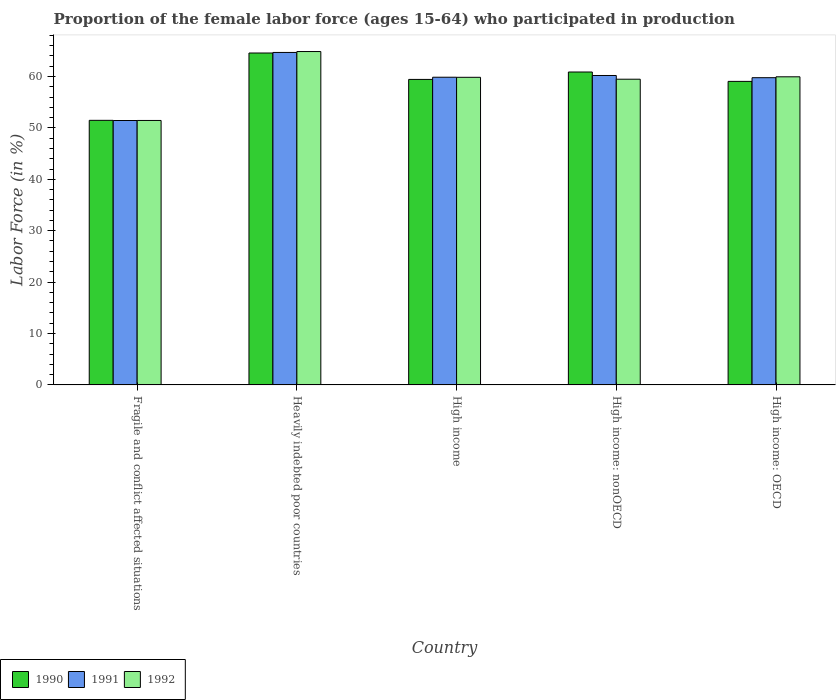How many groups of bars are there?
Keep it short and to the point. 5. Are the number of bars per tick equal to the number of legend labels?
Your answer should be compact. Yes. Are the number of bars on each tick of the X-axis equal?
Make the answer very short. Yes. How many bars are there on the 3rd tick from the left?
Provide a succinct answer. 3. How many bars are there on the 5th tick from the right?
Give a very brief answer. 3. What is the label of the 5th group of bars from the left?
Your response must be concise. High income: OECD. What is the proportion of the female labor force who participated in production in 1992 in Heavily indebted poor countries?
Keep it short and to the point. 64.85. Across all countries, what is the maximum proportion of the female labor force who participated in production in 1990?
Provide a short and direct response. 64.57. Across all countries, what is the minimum proportion of the female labor force who participated in production in 1992?
Your answer should be very brief. 51.44. In which country was the proportion of the female labor force who participated in production in 1992 maximum?
Your answer should be compact. Heavily indebted poor countries. In which country was the proportion of the female labor force who participated in production in 1990 minimum?
Keep it short and to the point. Fragile and conflict affected situations. What is the total proportion of the female labor force who participated in production in 1991 in the graph?
Make the answer very short. 295.93. What is the difference between the proportion of the female labor force who participated in production in 1991 in Fragile and conflict affected situations and that in Heavily indebted poor countries?
Your answer should be compact. -13.24. What is the difference between the proportion of the female labor force who participated in production in 1992 in High income: nonOECD and the proportion of the female labor force who participated in production in 1991 in High income?
Your answer should be compact. -0.38. What is the average proportion of the female labor force who participated in production in 1992 per country?
Your answer should be compact. 59.11. What is the difference between the proportion of the female labor force who participated in production of/in 1992 and proportion of the female labor force who participated in production of/in 1990 in Fragile and conflict affected situations?
Keep it short and to the point. -0.03. What is the ratio of the proportion of the female labor force who participated in production in 1990 in Fragile and conflict affected situations to that in High income: nonOECD?
Keep it short and to the point. 0.85. Is the proportion of the female labor force who participated in production in 1991 in Fragile and conflict affected situations less than that in High income: nonOECD?
Give a very brief answer. Yes. What is the difference between the highest and the second highest proportion of the female labor force who participated in production in 1992?
Provide a succinct answer. 5.01. What is the difference between the highest and the lowest proportion of the female labor force who participated in production in 1992?
Your answer should be very brief. 13.41. Is the sum of the proportion of the female labor force who participated in production in 1991 in Heavily indebted poor countries and High income: nonOECD greater than the maximum proportion of the female labor force who participated in production in 1992 across all countries?
Make the answer very short. Yes. Is it the case that in every country, the sum of the proportion of the female labor force who participated in production in 1991 and proportion of the female labor force who participated in production in 1992 is greater than the proportion of the female labor force who participated in production in 1990?
Provide a short and direct response. Yes. Are all the bars in the graph horizontal?
Offer a very short reply. No. How many countries are there in the graph?
Give a very brief answer. 5. Are the values on the major ticks of Y-axis written in scientific E-notation?
Offer a terse response. No. Does the graph contain grids?
Offer a terse response. No. Where does the legend appear in the graph?
Give a very brief answer. Bottom left. How are the legend labels stacked?
Provide a succinct answer. Horizontal. What is the title of the graph?
Your response must be concise. Proportion of the female labor force (ages 15-64) who participated in production. Does "1973" appear as one of the legend labels in the graph?
Give a very brief answer. No. What is the Labor Force (in %) of 1990 in Fragile and conflict affected situations?
Give a very brief answer. 51.47. What is the Labor Force (in %) in 1991 in Fragile and conflict affected situations?
Provide a succinct answer. 51.44. What is the Labor Force (in %) of 1992 in Fragile and conflict affected situations?
Keep it short and to the point. 51.44. What is the Labor Force (in %) of 1990 in Heavily indebted poor countries?
Your answer should be very brief. 64.57. What is the Labor Force (in %) in 1991 in Heavily indebted poor countries?
Provide a short and direct response. 64.68. What is the Labor Force (in %) of 1992 in Heavily indebted poor countries?
Provide a short and direct response. 64.85. What is the Labor Force (in %) of 1990 in High income?
Offer a very short reply. 59.43. What is the Labor Force (in %) in 1991 in High income?
Keep it short and to the point. 59.86. What is the Labor Force (in %) of 1992 in High income?
Provide a succinct answer. 59.84. What is the Labor Force (in %) in 1990 in High income: nonOECD?
Provide a short and direct response. 60.87. What is the Labor Force (in %) of 1991 in High income: nonOECD?
Your response must be concise. 60.19. What is the Labor Force (in %) in 1992 in High income: nonOECD?
Provide a short and direct response. 59.47. What is the Labor Force (in %) in 1990 in High income: OECD?
Your answer should be very brief. 59.05. What is the Labor Force (in %) of 1991 in High income: OECD?
Your answer should be compact. 59.77. What is the Labor Force (in %) in 1992 in High income: OECD?
Provide a succinct answer. 59.94. Across all countries, what is the maximum Labor Force (in %) of 1990?
Provide a short and direct response. 64.57. Across all countries, what is the maximum Labor Force (in %) in 1991?
Provide a short and direct response. 64.68. Across all countries, what is the maximum Labor Force (in %) in 1992?
Ensure brevity in your answer.  64.85. Across all countries, what is the minimum Labor Force (in %) in 1990?
Your response must be concise. 51.47. Across all countries, what is the minimum Labor Force (in %) in 1991?
Your answer should be very brief. 51.44. Across all countries, what is the minimum Labor Force (in %) in 1992?
Your response must be concise. 51.44. What is the total Labor Force (in %) of 1990 in the graph?
Provide a succinct answer. 295.39. What is the total Labor Force (in %) of 1991 in the graph?
Offer a terse response. 295.93. What is the total Labor Force (in %) in 1992 in the graph?
Make the answer very short. 295.55. What is the difference between the Labor Force (in %) in 1990 in Fragile and conflict affected situations and that in Heavily indebted poor countries?
Keep it short and to the point. -13.1. What is the difference between the Labor Force (in %) of 1991 in Fragile and conflict affected situations and that in Heavily indebted poor countries?
Provide a short and direct response. -13.24. What is the difference between the Labor Force (in %) in 1992 in Fragile and conflict affected situations and that in Heavily indebted poor countries?
Make the answer very short. -13.41. What is the difference between the Labor Force (in %) in 1990 in Fragile and conflict affected situations and that in High income?
Give a very brief answer. -7.96. What is the difference between the Labor Force (in %) in 1991 in Fragile and conflict affected situations and that in High income?
Give a very brief answer. -8.42. What is the difference between the Labor Force (in %) in 1992 in Fragile and conflict affected situations and that in High income?
Your response must be concise. -8.4. What is the difference between the Labor Force (in %) in 1990 in Fragile and conflict affected situations and that in High income: nonOECD?
Make the answer very short. -9.4. What is the difference between the Labor Force (in %) of 1991 in Fragile and conflict affected situations and that in High income: nonOECD?
Your answer should be very brief. -8.76. What is the difference between the Labor Force (in %) in 1992 in Fragile and conflict affected situations and that in High income: nonOECD?
Ensure brevity in your answer.  -8.03. What is the difference between the Labor Force (in %) of 1990 in Fragile and conflict affected situations and that in High income: OECD?
Provide a short and direct response. -7.58. What is the difference between the Labor Force (in %) in 1991 in Fragile and conflict affected situations and that in High income: OECD?
Your answer should be very brief. -8.33. What is the difference between the Labor Force (in %) of 1992 in Fragile and conflict affected situations and that in High income: OECD?
Give a very brief answer. -8.49. What is the difference between the Labor Force (in %) in 1990 in Heavily indebted poor countries and that in High income?
Provide a succinct answer. 5.14. What is the difference between the Labor Force (in %) of 1991 in Heavily indebted poor countries and that in High income?
Offer a very short reply. 4.82. What is the difference between the Labor Force (in %) of 1992 in Heavily indebted poor countries and that in High income?
Your answer should be compact. 5.01. What is the difference between the Labor Force (in %) in 1990 in Heavily indebted poor countries and that in High income: nonOECD?
Make the answer very short. 3.7. What is the difference between the Labor Force (in %) of 1991 in Heavily indebted poor countries and that in High income: nonOECD?
Keep it short and to the point. 4.48. What is the difference between the Labor Force (in %) in 1992 in Heavily indebted poor countries and that in High income: nonOECD?
Offer a terse response. 5.38. What is the difference between the Labor Force (in %) of 1990 in Heavily indebted poor countries and that in High income: OECD?
Give a very brief answer. 5.52. What is the difference between the Labor Force (in %) in 1991 in Heavily indebted poor countries and that in High income: OECD?
Make the answer very short. 4.91. What is the difference between the Labor Force (in %) in 1992 in Heavily indebted poor countries and that in High income: OECD?
Your response must be concise. 4.91. What is the difference between the Labor Force (in %) in 1990 in High income and that in High income: nonOECD?
Provide a short and direct response. -1.44. What is the difference between the Labor Force (in %) in 1991 in High income and that in High income: nonOECD?
Ensure brevity in your answer.  -0.34. What is the difference between the Labor Force (in %) of 1992 in High income and that in High income: nonOECD?
Provide a short and direct response. 0.37. What is the difference between the Labor Force (in %) of 1990 in High income and that in High income: OECD?
Provide a short and direct response. 0.38. What is the difference between the Labor Force (in %) of 1991 in High income and that in High income: OECD?
Your answer should be compact. 0.09. What is the difference between the Labor Force (in %) of 1992 in High income and that in High income: OECD?
Give a very brief answer. -0.1. What is the difference between the Labor Force (in %) in 1990 in High income: nonOECD and that in High income: OECD?
Keep it short and to the point. 1.82. What is the difference between the Labor Force (in %) in 1991 in High income: nonOECD and that in High income: OECD?
Provide a short and direct response. 0.43. What is the difference between the Labor Force (in %) of 1992 in High income: nonOECD and that in High income: OECD?
Offer a terse response. -0.47. What is the difference between the Labor Force (in %) of 1990 in Fragile and conflict affected situations and the Labor Force (in %) of 1991 in Heavily indebted poor countries?
Keep it short and to the point. -13.21. What is the difference between the Labor Force (in %) of 1990 in Fragile and conflict affected situations and the Labor Force (in %) of 1992 in Heavily indebted poor countries?
Your answer should be compact. -13.38. What is the difference between the Labor Force (in %) of 1991 in Fragile and conflict affected situations and the Labor Force (in %) of 1992 in Heavily indebted poor countries?
Keep it short and to the point. -13.42. What is the difference between the Labor Force (in %) of 1990 in Fragile and conflict affected situations and the Labor Force (in %) of 1991 in High income?
Make the answer very short. -8.38. What is the difference between the Labor Force (in %) of 1990 in Fragile and conflict affected situations and the Labor Force (in %) of 1992 in High income?
Your response must be concise. -8.37. What is the difference between the Labor Force (in %) of 1991 in Fragile and conflict affected situations and the Labor Force (in %) of 1992 in High income?
Your answer should be compact. -8.4. What is the difference between the Labor Force (in %) in 1990 in Fragile and conflict affected situations and the Labor Force (in %) in 1991 in High income: nonOECD?
Offer a terse response. -8.72. What is the difference between the Labor Force (in %) in 1990 in Fragile and conflict affected situations and the Labor Force (in %) in 1992 in High income: nonOECD?
Provide a short and direct response. -8. What is the difference between the Labor Force (in %) of 1991 in Fragile and conflict affected situations and the Labor Force (in %) of 1992 in High income: nonOECD?
Your response must be concise. -8.03. What is the difference between the Labor Force (in %) of 1990 in Fragile and conflict affected situations and the Labor Force (in %) of 1991 in High income: OECD?
Offer a terse response. -8.3. What is the difference between the Labor Force (in %) in 1990 in Fragile and conflict affected situations and the Labor Force (in %) in 1992 in High income: OECD?
Your answer should be compact. -8.47. What is the difference between the Labor Force (in %) of 1991 in Fragile and conflict affected situations and the Labor Force (in %) of 1992 in High income: OECD?
Offer a very short reply. -8.5. What is the difference between the Labor Force (in %) in 1990 in Heavily indebted poor countries and the Labor Force (in %) in 1991 in High income?
Make the answer very short. 4.71. What is the difference between the Labor Force (in %) of 1990 in Heavily indebted poor countries and the Labor Force (in %) of 1992 in High income?
Provide a succinct answer. 4.73. What is the difference between the Labor Force (in %) of 1991 in Heavily indebted poor countries and the Labor Force (in %) of 1992 in High income?
Ensure brevity in your answer.  4.84. What is the difference between the Labor Force (in %) in 1990 in Heavily indebted poor countries and the Labor Force (in %) in 1991 in High income: nonOECD?
Your answer should be compact. 4.37. What is the difference between the Labor Force (in %) in 1990 in Heavily indebted poor countries and the Labor Force (in %) in 1992 in High income: nonOECD?
Offer a very short reply. 5.1. What is the difference between the Labor Force (in %) of 1991 in Heavily indebted poor countries and the Labor Force (in %) of 1992 in High income: nonOECD?
Your answer should be very brief. 5.21. What is the difference between the Labor Force (in %) in 1990 in Heavily indebted poor countries and the Labor Force (in %) in 1991 in High income: OECD?
Provide a short and direct response. 4.8. What is the difference between the Labor Force (in %) of 1990 in Heavily indebted poor countries and the Labor Force (in %) of 1992 in High income: OECD?
Make the answer very short. 4.63. What is the difference between the Labor Force (in %) in 1991 in Heavily indebted poor countries and the Labor Force (in %) in 1992 in High income: OECD?
Your response must be concise. 4.74. What is the difference between the Labor Force (in %) in 1990 in High income and the Labor Force (in %) in 1991 in High income: nonOECD?
Provide a short and direct response. -0.76. What is the difference between the Labor Force (in %) of 1990 in High income and the Labor Force (in %) of 1992 in High income: nonOECD?
Offer a very short reply. -0.04. What is the difference between the Labor Force (in %) of 1991 in High income and the Labor Force (in %) of 1992 in High income: nonOECD?
Ensure brevity in your answer.  0.38. What is the difference between the Labor Force (in %) in 1990 in High income and the Labor Force (in %) in 1991 in High income: OECD?
Offer a very short reply. -0.34. What is the difference between the Labor Force (in %) in 1990 in High income and the Labor Force (in %) in 1992 in High income: OECD?
Provide a short and direct response. -0.51. What is the difference between the Labor Force (in %) in 1991 in High income and the Labor Force (in %) in 1992 in High income: OECD?
Offer a terse response. -0.08. What is the difference between the Labor Force (in %) in 1990 in High income: nonOECD and the Labor Force (in %) in 1991 in High income: OECD?
Make the answer very short. 1.11. What is the difference between the Labor Force (in %) of 1990 in High income: nonOECD and the Labor Force (in %) of 1992 in High income: OECD?
Your response must be concise. 0.93. What is the difference between the Labor Force (in %) in 1991 in High income: nonOECD and the Labor Force (in %) in 1992 in High income: OECD?
Keep it short and to the point. 0.25. What is the average Labor Force (in %) in 1990 per country?
Your answer should be compact. 59.08. What is the average Labor Force (in %) in 1991 per country?
Your response must be concise. 59.19. What is the average Labor Force (in %) of 1992 per country?
Provide a short and direct response. 59.11. What is the difference between the Labor Force (in %) in 1990 and Labor Force (in %) in 1991 in Fragile and conflict affected situations?
Keep it short and to the point. 0.03. What is the difference between the Labor Force (in %) in 1990 and Labor Force (in %) in 1992 in Fragile and conflict affected situations?
Make the answer very short. 0.03. What is the difference between the Labor Force (in %) in 1991 and Labor Force (in %) in 1992 in Fragile and conflict affected situations?
Offer a terse response. -0.01. What is the difference between the Labor Force (in %) in 1990 and Labor Force (in %) in 1991 in Heavily indebted poor countries?
Keep it short and to the point. -0.11. What is the difference between the Labor Force (in %) in 1990 and Labor Force (in %) in 1992 in Heavily indebted poor countries?
Provide a succinct answer. -0.28. What is the difference between the Labor Force (in %) in 1991 and Labor Force (in %) in 1992 in Heavily indebted poor countries?
Offer a very short reply. -0.18. What is the difference between the Labor Force (in %) of 1990 and Labor Force (in %) of 1991 in High income?
Offer a terse response. -0.43. What is the difference between the Labor Force (in %) of 1990 and Labor Force (in %) of 1992 in High income?
Provide a short and direct response. -0.41. What is the difference between the Labor Force (in %) of 1991 and Labor Force (in %) of 1992 in High income?
Offer a very short reply. 0.01. What is the difference between the Labor Force (in %) of 1990 and Labor Force (in %) of 1991 in High income: nonOECD?
Make the answer very short. 0.68. What is the difference between the Labor Force (in %) of 1990 and Labor Force (in %) of 1992 in High income: nonOECD?
Your answer should be compact. 1.4. What is the difference between the Labor Force (in %) of 1991 and Labor Force (in %) of 1992 in High income: nonOECD?
Offer a terse response. 0.72. What is the difference between the Labor Force (in %) of 1990 and Labor Force (in %) of 1991 in High income: OECD?
Your answer should be compact. -0.72. What is the difference between the Labor Force (in %) in 1990 and Labor Force (in %) in 1992 in High income: OECD?
Your answer should be very brief. -0.89. What is the difference between the Labor Force (in %) in 1991 and Labor Force (in %) in 1992 in High income: OECD?
Make the answer very short. -0.17. What is the ratio of the Labor Force (in %) of 1990 in Fragile and conflict affected situations to that in Heavily indebted poor countries?
Offer a terse response. 0.8. What is the ratio of the Labor Force (in %) of 1991 in Fragile and conflict affected situations to that in Heavily indebted poor countries?
Your response must be concise. 0.8. What is the ratio of the Labor Force (in %) in 1992 in Fragile and conflict affected situations to that in Heavily indebted poor countries?
Give a very brief answer. 0.79. What is the ratio of the Labor Force (in %) in 1990 in Fragile and conflict affected situations to that in High income?
Keep it short and to the point. 0.87. What is the ratio of the Labor Force (in %) in 1991 in Fragile and conflict affected situations to that in High income?
Make the answer very short. 0.86. What is the ratio of the Labor Force (in %) in 1992 in Fragile and conflict affected situations to that in High income?
Offer a terse response. 0.86. What is the ratio of the Labor Force (in %) in 1990 in Fragile and conflict affected situations to that in High income: nonOECD?
Your answer should be compact. 0.85. What is the ratio of the Labor Force (in %) of 1991 in Fragile and conflict affected situations to that in High income: nonOECD?
Ensure brevity in your answer.  0.85. What is the ratio of the Labor Force (in %) of 1992 in Fragile and conflict affected situations to that in High income: nonOECD?
Provide a short and direct response. 0.86. What is the ratio of the Labor Force (in %) in 1990 in Fragile and conflict affected situations to that in High income: OECD?
Ensure brevity in your answer.  0.87. What is the ratio of the Labor Force (in %) in 1991 in Fragile and conflict affected situations to that in High income: OECD?
Your answer should be compact. 0.86. What is the ratio of the Labor Force (in %) of 1992 in Fragile and conflict affected situations to that in High income: OECD?
Give a very brief answer. 0.86. What is the ratio of the Labor Force (in %) in 1990 in Heavily indebted poor countries to that in High income?
Ensure brevity in your answer.  1.09. What is the ratio of the Labor Force (in %) of 1991 in Heavily indebted poor countries to that in High income?
Your response must be concise. 1.08. What is the ratio of the Labor Force (in %) of 1992 in Heavily indebted poor countries to that in High income?
Provide a short and direct response. 1.08. What is the ratio of the Labor Force (in %) in 1990 in Heavily indebted poor countries to that in High income: nonOECD?
Give a very brief answer. 1.06. What is the ratio of the Labor Force (in %) in 1991 in Heavily indebted poor countries to that in High income: nonOECD?
Your answer should be very brief. 1.07. What is the ratio of the Labor Force (in %) in 1992 in Heavily indebted poor countries to that in High income: nonOECD?
Make the answer very short. 1.09. What is the ratio of the Labor Force (in %) in 1990 in Heavily indebted poor countries to that in High income: OECD?
Your response must be concise. 1.09. What is the ratio of the Labor Force (in %) in 1991 in Heavily indebted poor countries to that in High income: OECD?
Give a very brief answer. 1.08. What is the ratio of the Labor Force (in %) of 1992 in Heavily indebted poor countries to that in High income: OECD?
Your answer should be compact. 1.08. What is the ratio of the Labor Force (in %) of 1990 in High income to that in High income: nonOECD?
Ensure brevity in your answer.  0.98. What is the ratio of the Labor Force (in %) of 1991 in High income to that in High income: nonOECD?
Keep it short and to the point. 0.99. What is the ratio of the Labor Force (in %) in 1990 in High income to that in High income: OECD?
Make the answer very short. 1.01. What is the ratio of the Labor Force (in %) of 1990 in High income: nonOECD to that in High income: OECD?
Keep it short and to the point. 1.03. What is the ratio of the Labor Force (in %) in 1991 in High income: nonOECD to that in High income: OECD?
Offer a terse response. 1.01. What is the difference between the highest and the second highest Labor Force (in %) of 1990?
Your answer should be very brief. 3.7. What is the difference between the highest and the second highest Labor Force (in %) of 1991?
Your answer should be compact. 4.48. What is the difference between the highest and the second highest Labor Force (in %) of 1992?
Your response must be concise. 4.91. What is the difference between the highest and the lowest Labor Force (in %) of 1990?
Offer a very short reply. 13.1. What is the difference between the highest and the lowest Labor Force (in %) of 1991?
Make the answer very short. 13.24. What is the difference between the highest and the lowest Labor Force (in %) in 1992?
Your answer should be compact. 13.41. 